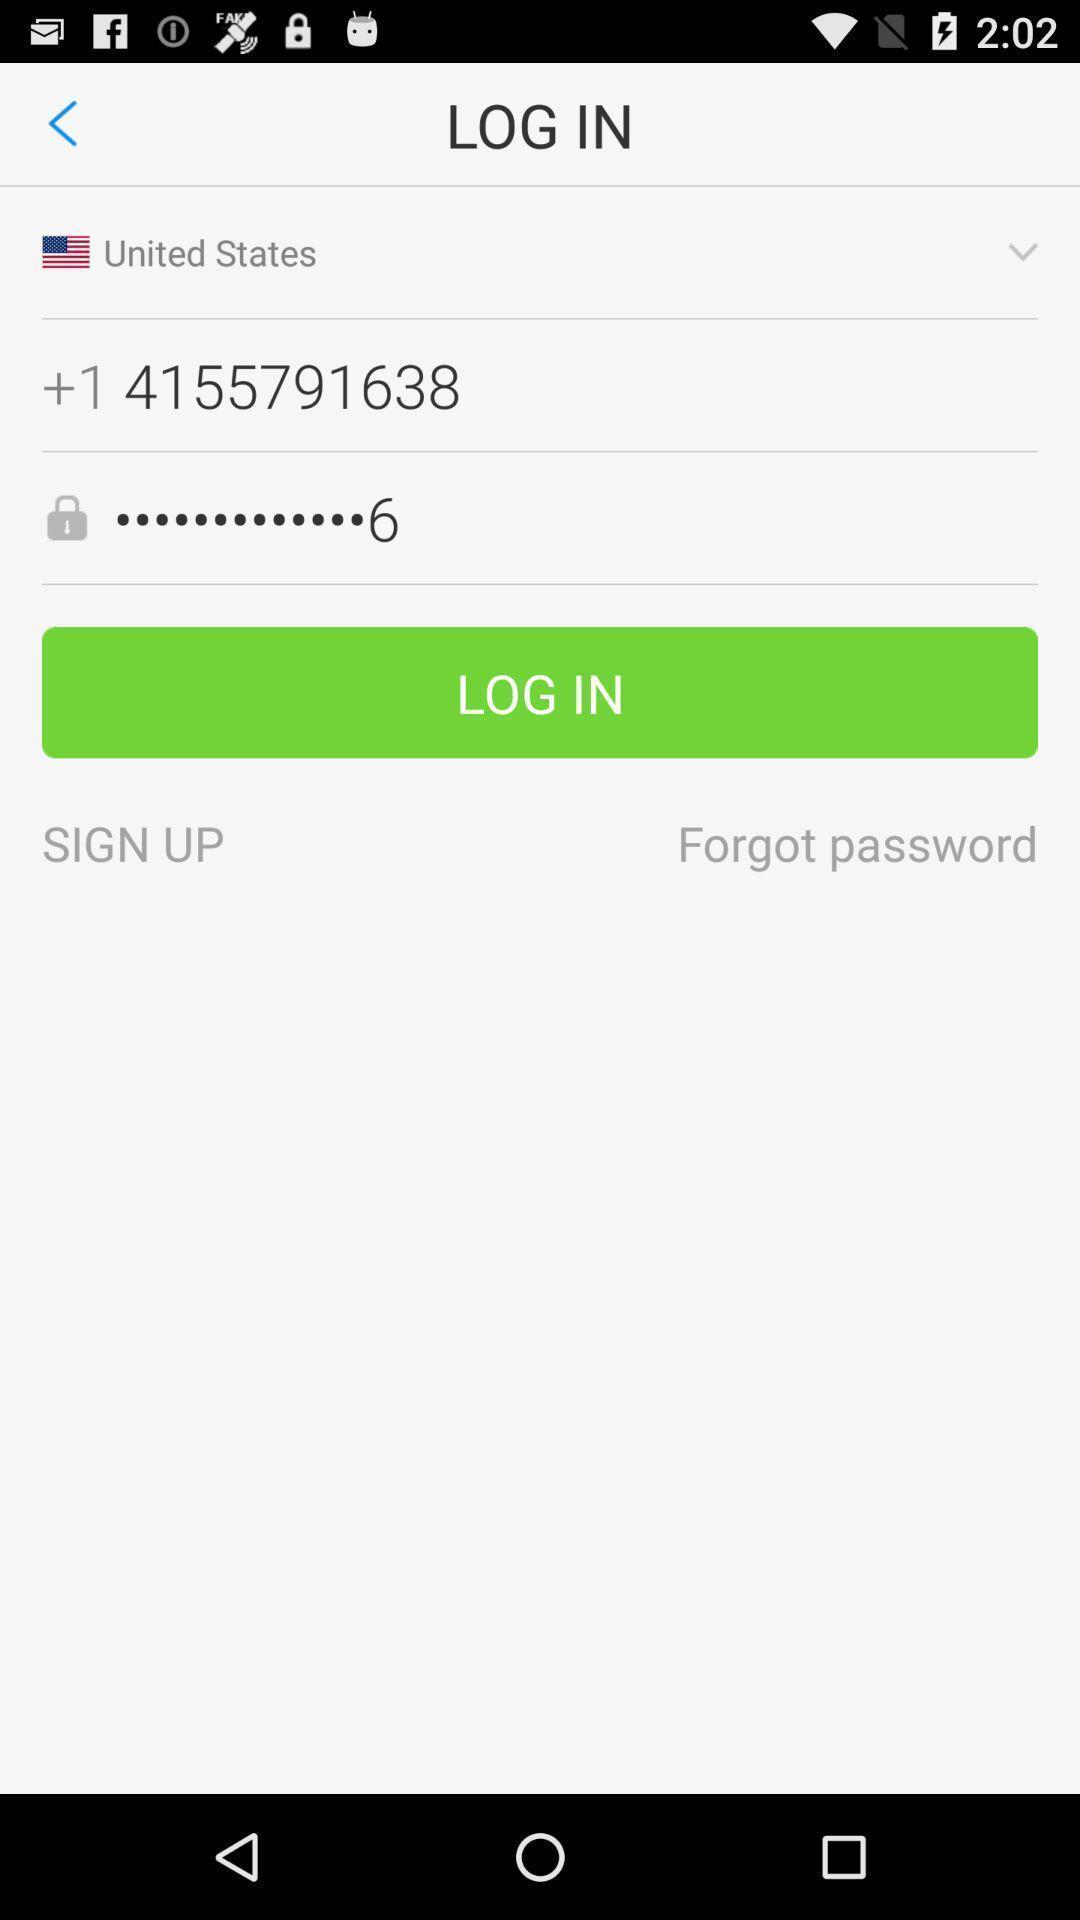Tell me about the visual elements in this screen capture. Login page which asks for the number and the password. 